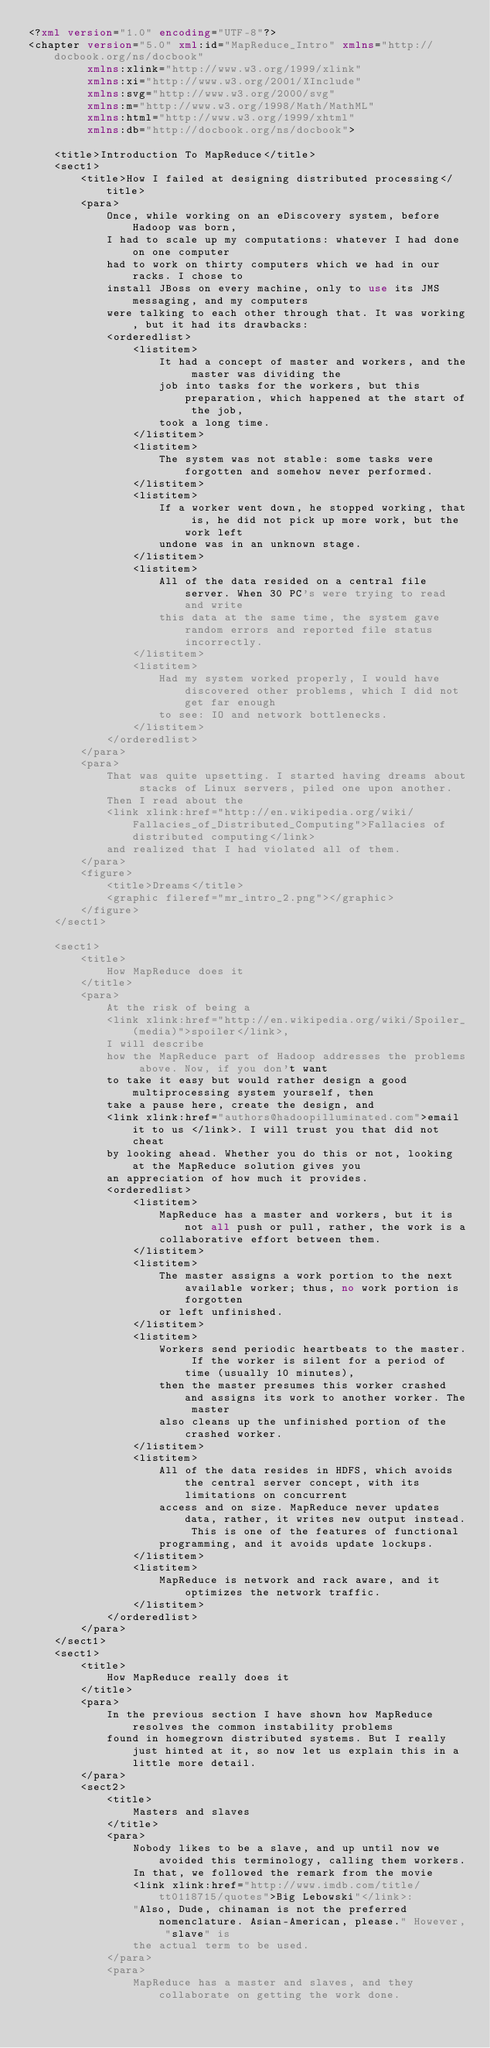<code> <loc_0><loc_0><loc_500><loc_500><_XML_><?xml version="1.0" encoding="UTF-8"?>
<chapter version="5.0" xml:id="MapReduce_Intro" xmlns="http://docbook.org/ns/docbook"
         xmlns:xlink="http://www.w3.org/1999/xlink"
         xmlns:xi="http://www.w3.org/2001/XInclude"
         xmlns:svg="http://www.w3.org/2000/svg"
         xmlns:m="http://www.w3.org/1998/Math/MathML"
         xmlns:html="http://www.w3.org/1999/xhtml"
         xmlns:db="http://docbook.org/ns/docbook">

    <title>Introduction To MapReduce</title>
    <sect1>
        <title>How I failed at designing distributed processing</title>
        <para>
            Once, while working on an eDiscovery system, before Hadoop was born,
            I had to scale up my computations: whatever I had done on one computer
            had to work on thirty computers which we had in our racks. I chose to
            install JBoss on every machine, only to use its JMS messaging, and my computers
            were talking to each other through that. It was working, but it had its drawbacks:
            <orderedlist>
                <listitem>
                    It had a concept of master and workers, and the master was dividing the
                    job into tasks for the workers, but this preparation, which happened at the start of the job,
                    took a long time.
                </listitem>
                <listitem>
                    The system was not stable: some tasks were forgotten and somehow never performed.
                </listitem>
                <listitem>
                    If a worker went down, he stopped working, that is, he did not pick up more work, but the work left
                    undone was in an unknown stage.
                </listitem>
                <listitem>
                    All of the data resided on a central file server. When 30 PC's were trying to read and write
                    this data at the same time, the system gave random errors and reported file status incorrectly.
                </listitem>
                <listitem>
                    Had my system worked properly, I would have discovered other problems, which I did not get far enough
                    to see: IO and network bottlenecks.
                </listitem>
            </orderedlist>
        </para>
        <para>
            That was quite upsetting. I started having dreams about stacks of Linux servers, piled one upon another.
            Then I read about the
            <link xlink:href="http://en.wikipedia.org/wiki/Fallacies_of_Distributed_Computing">Fallacies of distributed computing</link>
            and realized that I had violated all of them.
        </para>
        <figure>
            <title>Dreams</title>
            <graphic fileref="mr_intro_2.png"></graphic>
        </figure>
    </sect1>

    <sect1>
        <title>
            How MapReduce does it
        </title>
        <para>
            At the risk of being a
            <link xlink:href="http://en.wikipedia.org/wiki/Spoiler_(media)">spoiler</link>,
            I will describe
            how the MapReduce part of Hadoop addresses the problems above. Now, if you don't want
            to take it easy but would rather design a good multiprocessing system yourself, then
            take a pause here, create the design, and
            <link xlink:href="authors@hadoopilluminated.com">email it to us </link>. I will trust you that did not cheat
            by looking ahead. Whether you do this or not, looking at the MapReduce solution gives you
            an appreciation of how much it provides.
            <orderedlist>
                <listitem>
                    MapReduce has a master and workers, but it is not all push or pull, rather, the work is a
                    collaborative effort between them.
                </listitem>
                <listitem>
                    The master assigns a work portion to the next available worker; thus, no work portion is forgotten
                    or left unfinished.
                </listitem>
                <listitem>
                    Workers send periodic heartbeats to the master. If the worker is silent for a period of time (usually 10 minutes),
                    then the master presumes this worker crashed and assigns its work to another worker. The master
                    also cleans up the unfinished portion of the crashed worker.
                </listitem>
                <listitem>
                    All of the data resides in HDFS, which avoids the central server concept, with its limitations on concurrent
                    access and on size. MapReduce never updates data, rather, it writes new output instead. This is one of the features of functional
                    programming, and it avoids update lockups.
                </listitem>
                <listitem>
                    MapReduce is network and rack aware, and it optimizes the network traffic.
                </listitem>
            </orderedlist>
        </para>
    </sect1>
    <sect1>
        <title>
            How MapReduce really does it
        </title>
        <para>
            In the previous section I have shown how MapReduce resolves the common instability problems
            found in homegrown distributed systems. But I really just hinted at it, so now let us explain this in a little more detail.
        </para>
        <sect2>
            <title>
                Masters and slaves
            </title>
            <para>
                Nobody likes to be a slave, and up until now we avoided this terminology, calling them workers.
                In that, we followed the remark from the movie
                <link xlink:href="http://www.imdb.com/title/tt0118715/quotes">Big Lebowski"</link>:
                "Also, Dude, chinaman is not the preferred nomenclature. Asian-American, please." However, "slave" is
                the actual term to be used.
            </para>
            <para>
                MapReduce has a master and slaves, and they collaborate on getting the work done.</code> 